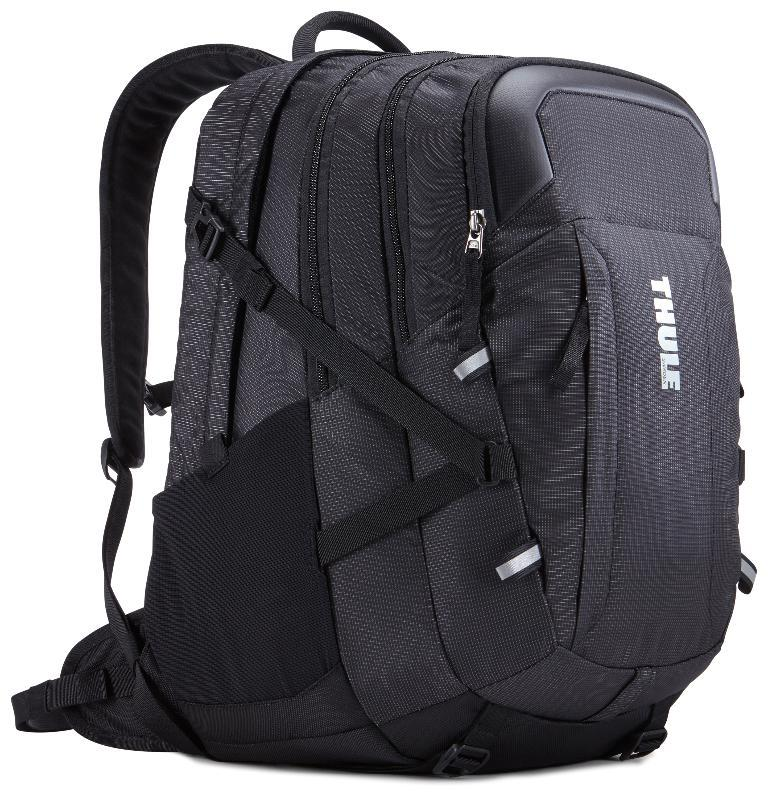What object can be seen in the image? There is a backpack in the image. What color is the backpack? The backpack is black in color. Can you see any veins in the backpack? There are no veins present in the backpack, as it is an inanimate object. 